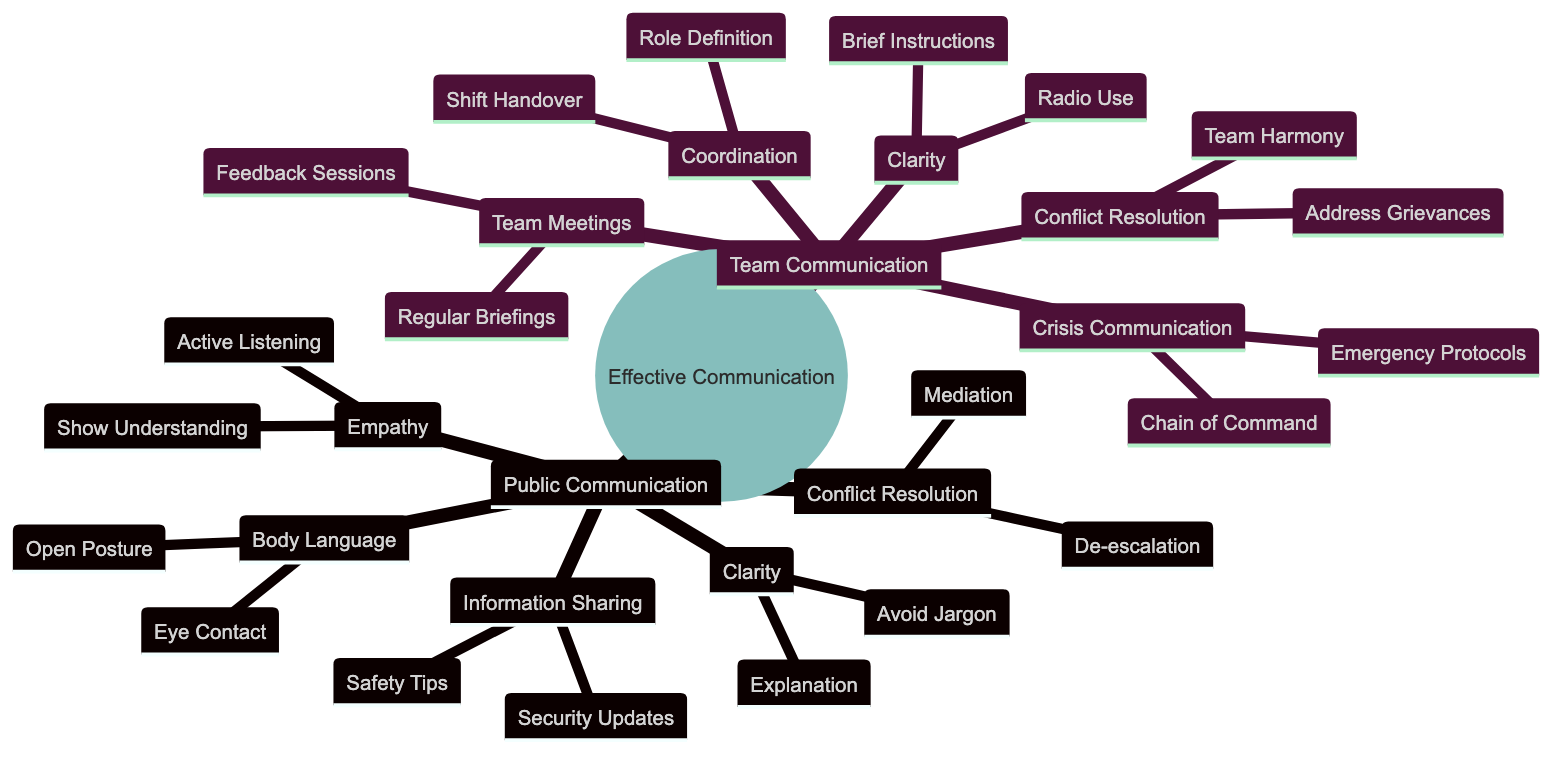What are the two main categories of communication in the diagram? The diagram has two main categories: Public Communication and Team Communication. These categories are the highest-level nodes stemming from the central concept of Effective Communication Skills.
Answer: Public Communication, Team Communication How many subcategories are under Public Communication? Under Public Communication, there are five subcategories: Clarity, Empathy, Body Language, Conflict Resolution, and Information Sharing. Counting these gives us the total number of subcategories in this section.
Answer: 5 What is one of the techniques listed under Conflict Resolution for Public Communication? One technique listed under Conflict Resolution is "De-escalation Techniques." This technique is explicitly mentioned in the section relating to how to resolve conflicts effectively while communicating with the public.
Answer: De-escalation Techniques What is the purpose of Regular Briefings in Team Communication? Regular Briefings are conducted to update team members on current situations and tasks. This indicates the importance of staying informed to aid effective team communication.
Answer: Update team members Which subcategory under Team Communication includes the system for team members to address grievances? The subcategory under Team Communication that includes addressing grievances is Conflict Resolution. This indicates that there is a focus on maintaining harmony and addressing issues within the team effectively.
Answer: Conflict Resolution What does Active Listening in the Empathy section aim to achieve? Active Listening aims to ensure that the communicator listens to the concerns and questions of the public. This is essential for building rapport and addressing public safety effectively.
Answer: Listen to concerns What is the relationship between "Role Definition" and "Coordination"? "Role Definition" is a subcategory under "Coordination," indicating that defining roles and responsibilities is crucial for ensuring an organized approach to teamwork. This shows how role clarity supports overall coordination.
Answer: Coordination How many tips are mentioned in the Information Sharing section? In the Information Sharing section, there are two tips mentioned: Security Updates and Safety Tips. These are key elements of effective information dissemination to the public.
Answer: 2 What is the theme of the Mind Map based on the diagram? The theme of the Mind Map centers on "Effective Communication Skills with the Public and Team Members." This overarching theme encapsulates all the categories and techniques presented in the diagram.
Answer: Effective Communication Skills 